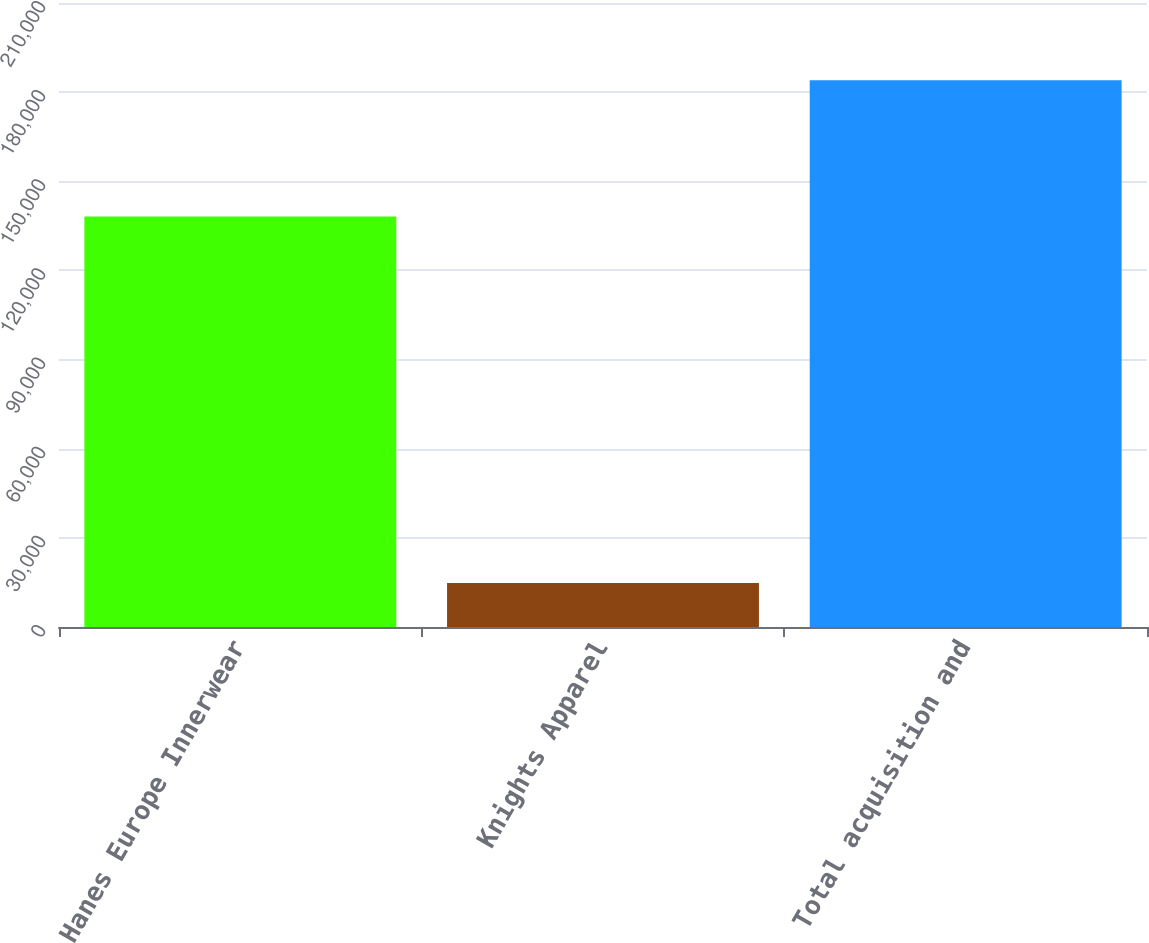Convert chart to OTSL. <chart><loc_0><loc_0><loc_500><loc_500><bar_chart><fcel>Hanes Europe Innerwear<fcel>Knights Apparel<fcel>Total acquisition and<nl><fcel>138116<fcel>14789<fcel>184019<nl></chart> 